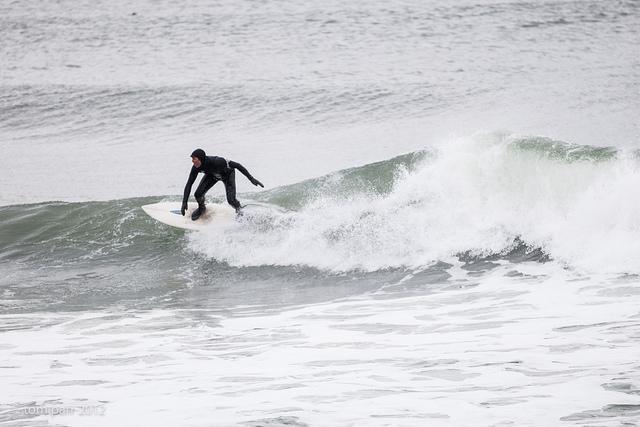How many surfers are there?
Be succinct. 1. Is the water calm?
Write a very short answer. No. What is the surfer wearing?
Be succinct. Wetsuit. 